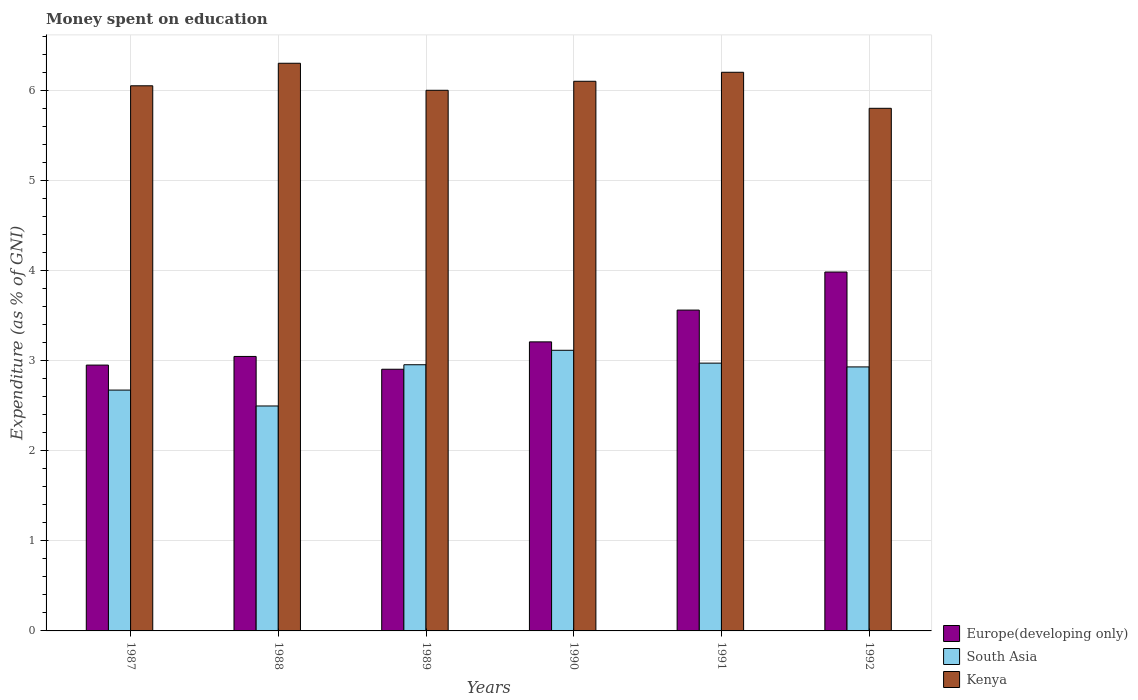How many groups of bars are there?
Offer a very short reply. 6. How many bars are there on the 6th tick from the right?
Ensure brevity in your answer.  3. What is the label of the 6th group of bars from the left?
Offer a very short reply. 1992. In how many cases, is the number of bars for a given year not equal to the number of legend labels?
Your response must be concise. 0. What is the amount of money spent on education in Europe(developing only) in 1987?
Provide a succinct answer. 2.95. What is the total amount of money spent on education in South Asia in the graph?
Make the answer very short. 17.14. What is the difference between the amount of money spent on education in Europe(developing only) in 1987 and that in 1988?
Offer a terse response. -0.1. What is the difference between the amount of money spent on education in Kenya in 1992 and the amount of money spent on education in South Asia in 1990?
Give a very brief answer. 2.69. What is the average amount of money spent on education in Kenya per year?
Provide a short and direct response. 6.08. In the year 1992, what is the difference between the amount of money spent on education in Europe(developing only) and amount of money spent on education in South Asia?
Your answer should be very brief. 1.05. What is the ratio of the amount of money spent on education in South Asia in 1988 to that in 1990?
Your answer should be very brief. 0.8. Is the difference between the amount of money spent on education in Europe(developing only) in 1989 and 1990 greater than the difference between the amount of money spent on education in South Asia in 1989 and 1990?
Make the answer very short. No. What is the difference between the highest and the second highest amount of money spent on education in South Asia?
Offer a terse response. 0.14. What is the difference between the highest and the lowest amount of money spent on education in Europe(developing only)?
Provide a short and direct response. 1.08. Is the sum of the amount of money spent on education in South Asia in 1988 and 1992 greater than the maximum amount of money spent on education in Kenya across all years?
Your answer should be very brief. No. What does the 2nd bar from the left in 1988 represents?
Offer a very short reply. South Asia. Is it the case that in every year, the sum of the amount of money spent on education in Kenya and amount of money spent on education in Europe(developing only) is greater than the amount of money spent on education in South Asia?
Your answer should be very brief. Yes. How many bars are there?
Your answer should be very brief. 18. How many legend labels are there?
Ensure brevity in your answer.  3. How are the legend labels stacked?
Ensure brevity in your answer.  Vertical. What is the title of the graph?
Provide a succinct answer. Money spent on education. Does "Isle of Man" appear as one of the legend labels in the graph?
Your answer should be compact. No. What is the label or title of the X-axis?
Provide a short and direct response. Years. What is the label or title of the Y-axis?
Make the answer very short. Expenditure (as % of GNI). What is the Expenditure (as % of GNI) in Europe(developing only) in 1987?
Provide a short and direct response. 2.95. What is the Expenditure (as % of GNI) in South Asia in 1987?
Your answer should be very brief. 2.67. What is the Expenditure (as % of GNI) of Kenya in 1987?
Your answer should be compact. 6.05. What is the Expenditure (as % of GNI) in Europe(developing only) in 1988?
Keep it short and to the point. 3.05. What is the Expenditure (as % of GNI) of South Asia in 1988?
Make the answer very short. 2.5. What is the Expenditure (as % of GNI) in Europe(developing only) in 1989?
Provide a short and direct response. 2.9. What is the Expenditure (as % of GNI) in South Asia in 1989?
Your answer should be compact. 2.95. What is the Expenditure (as % of GNI) of Kenya in 1989?
Your response must be concise. 6. What is the Expenditure (as % of GNI) of Europe(developing only) in 1990?
Keep it short and to the point. 3.21. What is the Expenditure (as % of GNI) in South Asia in 1990?
Offer a terse response. 3.11. What is the Expenditure (as % of GNI) of Kenya in 1990?
Give a very brief answer. 6.1. What is the Expenditure (as % of GNI) of Europe(developing only) in 1991?
Your answer should be compact. 3.56. What is the Expenditure (as % of GNI) in South Asia in 1991?
Your answer should be very brief. 2.97. What is the Expenditure (as % of GNI) in Europe(developing only) in 1992?
Give a very brief answer. 3.98. What is the Expenditure (as % of GNI) in South Asia in 1992?
Offer a very short reply. 2.93. What is the Expenditure (as % of GNI) in Kenya in 1992?
Keep it short and to the point. 5.8. Across all years, what is the maximum Expenditure (as % of GNI) in Europe(developing only)?
Your answer should be very brief. 3.98. Across all years, what is the maximum Expenditure (as % of GNI) of South Asia?
Give a very brief answer. 3.11. Across all years, what is the maximum Expenditure (as % of GNI) of Kenya?
Your answer should be compact. 6.3. Across all years, what is the minimum Expenditure (as % of GNI) in Europe(developing only)?
Keep it short and to the point. 2.9. Across all years, what is the minimum Expenditure (as % of GNI) of South Asia?
Your answer should be compact. 2.5. Across all years, what is the minimum Expenditure (as % of GNI) of Kenya?
Make the answer very short. 5.8. What is the total Expenditure (as % of GNI) of Europe(developing only) in the graph?
Your answer should be very brief. 19.65. What is the total Expenditure (as % of GNI) of South Asia in the graph?
Provide a succinct answer. 17.14. What is the total Expenditure (as % of GNI) of Kenya in the graph?
Give a very brief answer. 36.45. What is the difference between the Expenditure (as % of GNI) of Europe(developing only) in 1987 and that in 1988?
Offer a terse response. -0.1. What is the difference between the Expenditure (as % of GNI) in South Asia in 1987 and that in 1988?
Your answer should be compact. 0.18. What is the difference between the Expenditure (as % of GNI) of Kenya in 1987 and that in 1988?
Offer a very short reply. -0.25. What is the difference between the Expenditure (as % of GNI) in Europe(developing only) in 1987 and that in 1989?
Give a very brief answer. 0.05. What is the difference between the Expenditure (as % of GNI) of South Asia in 1987 and that in 1989?
Make the answer very short. -0.28. What is the difference between the Expenditure (as % of GNI) of Europe(developing only) in 1987 and that in 1990?
Offer a terse response. -0.26. What is the difference between the Expenditure (as % of GNI) in South Asia in 1987 and that in 1990?
Your response must be concise. -0.44. What is the difference between the Expenditure (as % of GNI) in Kenya in 1987 and that in 1990?
Provide a short and direct response. -0.05. What is the difference between the Expenditure (as % of GNI) in Europe(developing only) in 1987 and that in 1991?
Give a very brief answer. -0.61. What is the difference between the Expenditure (as % of GNI) of South Asia in 1987 and that in 1991?
Offer a terse response. -0.3. What is the difference between the Expenditure (as % of GNI) of Europe(developing only) in 1987 and that in 1992?
Provide a short and direct response. -1.03. What is the difference between the Expenditure (as % of GNI) in South Asia in 1987 and that in 1992?
Offer a terse response. -0.26. What is the difference between the Expenditure (as % of GNI) of Kenya in 1987 and that in 1992?
Provide a short and direct response. 0.25. What is the difference between the Expenditure (as % of GNI) in Europe(developing only) in 1988 and that in 1989?
Offer a terse response. 0.14. What is the difference between the Expenditure (as % of GNI) of South Asia in 1988 and that in 1989?
Make the answer very short. -0.46. What is the difference between the Expenditure (as % of GNI) in Europe(developing only) in 1988 and that in 1990?
Keep it short and to the point. -0.16. What is the difference between the Expenditure (as % of GNI) in South Asia in 1988 and that in 1990?
Offer a very short reply. -0.62. What is the difference between the Expenditure (as % of GNI) in Europe(developing only) in 1988 and that in 1991?
Ensure brevity in your answer.  -0.51. What is the difference between the Expenditure (as % of GNI) in South Asia in 1988 and that in 1991?
Make the answer very short. -0.48. What is the difference between the Expenditure (as % of GNI) in Europe(developing only) in 1988 and that in 1992?
Ensure brevity in your answer.  -0.94. What is the difference between the Expenditure (as % of GNI) of South Asia in 1988 and that in 1992?
Ensure brevity in your answer.  -0.43. What is the difference between the Expenditure (as % of GNI) in Kenya in 1988 and that in 1992?
Provide a short and direct response. 0.5. What is the difference between the Expenditure (as % of GNI) of Europe(developing only) in 1989 and that in 1990?
Give a very brief answer. -0.3. What is the difference between the Expenditure (as % of GNI) of South Asia in 1989 and that in 1990?
Your answer should be compact. -0.16. What is the difference between the Expenditure (as % of GNI) in Europe(developing only) in 1989 and that in 1991?
Provide a short and direct response. -0.66. What is the difference between the Expenditure (as % of GNI) of South Asia in 1989 and that in 1991?
Make the answer very short. -0.02. What is the difference between the Expenditure (as % of GNI) in Europe(developing only) in 1989 and that in 1992?
Keep it short and to the point. -1.08. What is the difference between the Expenditure (as % of GNI) in South Asia in 1989 and that in 1992?
Give a very brief answer. 0.02. What is the difference between the Expenditure (as % of GNI) of Europe(developing only) in 1990 and that in 1991?
Ensure brevity in your answer.  -0.35. What is the difference between the Expenditure (as % of GNI) in South Asia in 1990 and that in 1991?
Offer a terse response. 0.14. What is the difference between the Expenditure (as % of GNI) in Kenya in 1990 and that in 1991?
Provide a short and direct response. -0.1. What is the difference between the Expenditure (as % of GNI) in Europe(developing only) in 1990 and that in 1992?
Offer a terse response. -0.78. What is the difference between the Expenditure (as % of GNI) in South Asia in 1990 and that in 1992?
Your answer should be compact. 0.18. What is the difference between the Expenditure (as % of GNI) in Europe(developing only) in 1991 and that in 1992?
Your response must be concise. -0.42. What is the difference between the Expenditure (as % of GNI) of South Asia in 1991 and that in 1992?
Your response must be concise. 0.04. What is the difference between the Expenditure (as % of GNI) of Europe(developing only) in 1987 and the Expenditure (as % of GNI) of South Asia in 1988?
Provide a succinct answer. 0.45. What is the difference between the Expenditure (as % of GNI) of Europe(developing only) in 1987 and the Expenditure (as % of GNI) of Kenya in 1988?
Keep it short and to the point. -3.35. What is the difference between the Expenditure (as % of GNI) of South Asia in 1987 and the Expenditure (as % of GNI) of Kenya in 1988?
Make the answer very short. -3.63. What is the difference between the Expenditure (as % of GNI) in Europe(developing only) in 1987 and the Expenditure (as % of GNI) in South Asia in 1989?
Your answer should be compact. -0. What is the difference between the Expenditure (as % of GNI) of Europe(developing only) in 1987 and the Expenditure (as % of GNI) of Kenya in 1989?
Give a very brief answer. -3.05. What is the difference between the Expenditure (as % of GNI) in South Asia in 1987 and the Expenditure (as % of GNI) in Kenya in 1989?
Provide a short and direct response. -3.33. What is the difference between the Expenditure (as % of GNI) in Europe(developing only) in 1987 and the Expenditure (as % of GNI) in South Asia in 1990?
Make the answer very short. -0.16. What is the difference between the Expenditure (as % of GNI) in Europe(developing only) in 1987 and the Expenditure (as % of GNI) in Kenya in 1990?
Your response must be concise. -3.15. What is the difference between the Expenditure (as % of GNI) in South Asia in 1987 and the Expenditure (as % of GNI) in Kenya in 1990?
Provide a short and direct response. -3.43. What is the difference between the Expenditure (as % of GNI) in Europe(developing only) in 1987 and the Expenditure (as % of GNI) in South Asia in 1991?
Provide a short and direct response. -0.02. What is the difference between the Expenditure (as % of GNI) in Europe(developing only) in 1987 and the Expenditure (as % of GNI) in Kenya in 1991?
Your answer should be very brief. -3.25. What is the difference between the Expenditure (as % of GNI) of South Asia in 1987 and the Expenditure (as % of GNI) of Kenya in 1991?
Provide a short and direct response. -3.53. What is the difference between the Expenditure (as % of GNI) of Europe(developing only) in 1987 and the Expenditure (as % of GNI) of South Asia in 1992?
Give a very brief answer. 0.02. What is the difference between the Expenditure (as % of GNI) in Europe(developing only) in 1987 and the Expenditure (as % of GNI) in Kenya in 1992?
Provide a short and direct response. -2.85. What is the difference between the Expenditure (as % of GNI) in South Asia in 1987 and the Expenditure (as % of GNI) in Kenya in 1992?
Your response must be concise. -3.13. What is the difference between the Expenditure (as % of GNI) of Europe(developing only) in 1988 and the Expenditure (as % of GNI) of South Asia in 1989?
Provide a succinct answer. 0.09. What is the difference between the Expenditure (as % of GNI) in Europe(developing only) in 1988 and the Expenditure (as % of GNI) in Kenya in 1989?
Give a very brief answer. -2.95. What is the difference between the Expenditure (as % of GNI) in South Asia in 1988 and the Expenditure (as % of GNI) in Kenya in 1989?
Offer a very short reply. -3.5. What is the difference between the Expenditure (as % of GNI) of Europe(developing only) in 1988 and the Expenditure (as % of GNI) of South Asia in 1990?
Provide a succinct answer. -0.07. What is the difference between the Expenditure (as % of GNI) of Europe(developing only) in 1988 and the Expenditure (as % of GNI) of Kenya in 1990?
Your response must be concise. -3.05. What is the difference between the Expenditure (as % of GNI) in South Asia in 1988 and the Expenditure (as % of GNI) in Kenya in 1990?
Offer a terse response. -3.6. What is the difference between the Expenditure (as % of GNI) in Europe(developing only) in 1988 and the Expenditure (as % of GNI) in South Asia in 1991?
Your answer should be compact. 0.07. What is the difference between the Expenditure (as % of GNI) in Europe(developing only) in 1988 and the Expenditure (as % of GNI) in Kenya in 1991?
Your response must be concise. -3.15. What is the difference between the Expenditure (as % of GNI) of South Asia in 1988 and the Expenditure (as % of GNI) of Kenya in 1991?
Keep it short and to the point. -3.7. What is the difference between the Expenditure (as % of GNI) in Europe(developing only) in 1988 and the Expenditure (as % of GNI) in South Asia in 1992?
Ensure brevity in your answer.  0.12. What is the difference between the Expenditure (as % of GNI) of Europe(developing only) in 1988 and the Expenditure (as % of GNI) of Kenya in 1992?
Keep it short and to the point. -2.75. What is the difference between the Expenditure (as % of GNI) in South Asia in 1988 and the Expenditure (as % of GNI) in Kenya in 1992?
Make the answer very short. -3.3. What is the difference between the Expenditure (as % of GNI) of Europe(developing only) in 1989 and the Expenditure (as % of GNI) of South Asia in 1990?
Your answer should be very brief. -0.21. What is the difference between the Expenditure (as % of GNI) of Europe(developing only) in 1989 and the Expenditure (as % of GNI) of Kenya in 1990?
Your answer should be compact. -3.2. What is the difference between the Expenditure (as % of GNI) in South Asia in 1989 and the Expenditure (as % of GNI) in Kenya in 1990?
Make the answer very short. -3.15. What is the difference between the Expenditure (as % of GNI) of Europe(developing only) in 1989 and the Expenditure (as % of GNI) of South Asia in 1991?
Provide a short and direct response. -0.07. What is the difference between the Expenditure (as % of GNI) of Europe(developing only) in 1989 and the Expenditure (as % of GNI) of Kenya in 1991?
Your response must be concise. -3.3. What is the difference between the Expenditure (as % of GNI) of South Asia in 1989 and the Expenditure (as % of GNI) of Kenya in 1991?
Ensure brevity in your answer.  -3.25. What is the difference between the Expenditure (as % of GNI) in Europe(developing only) in 1989 and the Expenditure (as % of GNI) in South Asia in 1992?
Make the answer very short. -0.03. What is the difference between the Expenditure (as % of GNI) of Europe(developing only) in 1989 and the Expenditure (as % of GNI) of Kenya in 1992?
Offer a terse response. -2.9. What is the difference between the Expenditure (as % of GNI) of South Asia in 1989 and the Expenditure (as % of GNI) of Kenya in 1992?
Provide a succinct answer. -2.85. What is the difference between the Expenditure (as % of GNI) of Europe(developing only) in 1990 and the Expenditure (as % of GNI) of South Asia in 1991?
Ensure brevity in your answer.  0.24. What is the difference between the Expenditure (as % of GNI) of Europe(developing only) in 1990 and the Expenditure (as % of GNI) of Kenya in 1991?
Keep it short and to the point. -2.99. What is the difference between the Expenditure (as % of GNI) in South Asia in 1990 and the Expenditure (as % of GNI) in Kenya in 1991?
Offer a terse response. -3.09. What is the difference between the Expenditure (as % of GNI) in Europe(developing only) in 1990 and the Expenditure (as % of GNI) in South Asia in 1992?
Provide a short and direct response. 0.28. What is the difference between the Expenditure (as % of GNI) of Europe(developing only) in 1990 and the Expenditure (as % of GNI) of Kenya in 1992?
Your answer should be compact. -2.59. What is the difference between the Expenditure (as % of GNI) in South Asia in 1990 and the Expenditure (as % of GNI) in Kenya in 1992?
Your answer should be compact. -2.69. What is the difference between the Expenditure (as % of GNI) of Europe(developing only) in 1991 and the Expenditure (as % of GNI) of South Asia in 1992?
Your answer should be compact. 0.63. What is the difference between the Expenditure (as % of GNI) in Europe(developing only) in 1991 and the Expenditure (as % of GNI) in Kenya in 1992?
Offer a very short reply. -2.24. What is the difference between the Expenditure (as % of GNI) in South Asia in 1991 and the Expenditure (as % of GNI) in Kenya in 1992?
Make the answer very short. -2.83. What is the average Expenditure (as % of GNI) in Europe(developing only) per year?
Keep it short and to the point. 3.28. What is the average Expenditure (as % of GNI) in South Asia per year?
Provide a short and direct response. 2.86. What is the average Expenditure (as % of GNI) in Kenya per year?
Your response must be concise. 6.08. In the year 1987, what is the difference between the Expenditure (as % of GNI) of Europe(developing only) and Expenditure (as % of GNI) of South Asia?
Your answer should be very brief. 0.28. In the year 1987, what is the difference between the Expenditure (as % of GNI) of Europe(developing only) and Expenditure (as % of GNI) of Kenya?
Ensure brevity in your answer.  -3.1. In the year 1987, what is the difference between the Expenditure (as % of GNI) of South Asia and Expenditure (as % of GNI) of Kenya?
Offer a very short reply. -3.38. In the year 1988, what is the difference between the Expenditure (as % of GNI) in Europe(developing only) and Expenditure (as % of GNI) in South Asia?
Ensure brevity in your answer.  0.55. In the year 1988, what is the difference between the Expenditure (as % of GNI) in Europe(developing only) and Expenditure (as % of GNI) in Kenya?
Make the answer very short. -3.25. In the year 1988, what is the difference between the Expenditure (as % of GNI) in South Asia and Expenditure (as % of GNI) in Kenya?
Provide a succinct answer. -3.8. In the year 1989, what is the difference between the Expenditure (as % of GNI) of Europe(developing only) and Expenditure (as % of GNI) of South Asia?
Provide a succinct answer. -0.05. In the year 1989, what is the difference between the Expenditure (as % of GNI) of Europe(developing only) and Expenditure (as % of GNI) of Kenya?
Offer a terse response. -3.1. In the year 1989, what is the difference between the Expenditure (as % of GNI) in South Asia and Expenditure (as % of GNI) in Kenya?
Provide a short and direct response. -3.05. In the year 1990, what is the difference between the Expenditure (as % of GNI) in Europe(developing only) and Expenditure (as % of GNI) in South Asia?
Ensure brevity in your answer.  0.09. In the year 1990, what is the difference between the Expenditure (as % of GNI) of Europe(developing only) and Expenditure (as % of GNI) of Kenya?
Provide a short and direct response. -2.89. In the year 1990, what is the difference between the Expenditure (as % of GNI) in South Asia and Expenditure (as % of GNI) in Kenya?
Your answer should be very brief. -2.99. In the year 1991, what is the difference between the Expenditure (as % of GNI) in Europe(developing only) and Expenditure (as % of GNI) in South Asia?
Give a very brief answer. 0.59. In the year 1991, what is the difference between the Expenditure (as % of GNI) of Europe(developing only) and Expenditure (as % of GNI) of Kenya?
Provide a succinct answer. -2.64. In the year 1991, what is the difference between the Expenditure (as % of GNI) in South Asia and Expenditure (as % of GNI) in Kenya?
Keep it short and to the point. -3.23. In the year 1992, what is the difference between the Expenditure (as % of GNI) of Europe(developing only) and Expenditure (as % of GNI) of South Asia?
Make the answer very short. 1.05. In the year 1992, what is the difference between the Expenditure (as % of GNI) of Europe(developing only) and Expenditure (as % of GNI) of Kenya?
Offer a terse response. -1.82. In the year 1992, what is the difference between the Expenditure (as % of GNI) in South Asia and Expenditure (as % of GNI) in Kenya?
Your response must be concise. -2.87. What is the ratio of the Expenditure (as % of GNI) of Europe(developing only) in 1987 to that in 1988?
Your answer should be compact. 0.97. What is the ratio of the Expenditure (as % of GNI) of South Asia in 1987 to that in 1988?
Give a very brief answer. 1.07. What is the ratio of the Expenditure (as % of GNI) of Kenya in 1987 to that in 1988?
Ensure brevity in your answer.  0.96. What is the ratio of the Expenditure (as % of GNI) in Europe(developing only) in 1987 to that in 1989?
Make the answer very short. 1.02. What is the ratio of the Expenditure (as % of GNI) of South Asia in 1987 to that in 1989?
Give a very brief answer. 0.9. What is the ratio of the Expenditure (as % of GNI) in Kenya in 1987 to that in 1989?
Provide a short and direct response. 1.01. What is the ratio of the Expenditure (as % of GNI) in Europe(developing only) in 1987 to that in 1990?
Your response must be concise. 0.92. What is the ratio of the Expenditure (as % of GNI) of South Asia in 1987 to that in 1990?
Your answer should be very brief. 0.86. What is the ratio of the Expenditure (as % of GNI) of Europe(developing only) in 1987 to that in 1991?
Ensure brevity in your answer.  0.83. What is the ratio of the Expenditure (as % of GNI) in South Asia in 1987 to that in 1991?
Offer a terse response. 0.9. What is the ratio of the Expenditure (as % of GNI) in Kenya in 1987 to that in 1991?
Provide a succinct answer. 0.98. What is the ratio of the Expenditure (as % of GNI) of Europe(developing only) in 1987 to that in 1992?
Your response must be concise. 0.74. What is the ratio of the Expenditure (as % of GNI) in South Asia in 1987 to that in 1992?
Make the answer very short. 0.91. What is the ratio of the Expenditure (as % of GNI) of Kenya in 1987 to that in 1992?
Keep it short and to the point. 1.04. What is the ratio of the Expenditure (as % of GNI) of Europe(developing only) in 1988 to that in 1989?
Your response must be concise. 1.05. What is the ratio of the Expenditure (as % of GNI) of South Asia in 1988 to that in 1989?
Provide a short and direct response. 0.85. What is the ratio of the Expenditure (as % of GNI) in Kenya in 1988 to that in 1989?
Make the answer very short. 1.05. What is the ratio of the Expenditure (as % of GNI) in Europe(developing only) in 1988 to that in 1990?
Ensure brevity in your answer.  0.95. What is the ratio of the Expenditure (as % of GNI) of South Asia in 1988 to that in 1990?
Offer a terse response. 0.8. What is the ratio of the Expenditure (as % of GNI) in Kenya in 1988 to that in 1990?
Keep it short and to the point. 1.03. What is the ratio of the Expenditure (as % of GNI) in Europe(developing only) in 1988 to that in 1991?
Your answer should be very brief. 0.86. What is the ratio of the Expenditure (as % of GNI) in South Asia in 1988 to that in 1991?
Offer a very short reply. 0.84. What is the ratio of the Expenditure (as % of GNI) of Kenya in 1988 to that in 1991?
Give a very brief answer. 1.02. What is the ratio of the Expenditure (as % of GNI) in Europe(developing only) in 1988 to that in 1992?
Provide a succinct answer. 0.76. What is the ratio of the Expenditure (as % of GNI) in South Asia in 1988 to that in 1992?
Make the answer very short. 0.85. What is the ratio of the Expenditure (as % of GNI) of Kenya in 1988 to that in 1992?
Offer a very short reply. 1.09. What is the ratio of the Expenditure (as % of GNI) of Europe(developing only) in 1989 to that in 1990?
Ensure brevity in your answer.  0.91. What is the ratio of the Expenditure (as % of GNI) in South Asia in 1989 to that in 1990?
Ensure brevity in your answer.  0.95. What is the ratio of the Expenditure (as % of GNI) of Kenya in 1989 to that in 1990?
Ensure brevity in your answer.  0.98. What is the ratio of the Expenditure (as % of GNI) of Europe(developing only) in 1989 to that in 1991?
Ensure brevity in your answer.  0.82. What is the ratio of the Expenditure (as % of GNI) of Europe(developing only) in 1989 to that in 1992?
Your response must be concise. 0.73. What is the ratio of the Expenditure (as % of GNI) of South Asia in 1989 to that in 1992?
Your answer should be very brief. 1.01. What is the ratio of the Expenditure (as % of GNI) in Kenya in 1989 to that in 1992?
Ensure brevity in your answer.  1.03. What is the ratio of the Expenditure (as % of GNI) in Europe(developing only) in 1990 to that in 1991?
Make the answer very short. 0.9. What is the ratio of the Expenditure (as % of GNI) of South Asia in 1990 to that in 1991?
Make the answer very short. 1.05. What is the ratio of the Expenditure (as % of GNI) in Kenya in 1990 to that in 1991?
Your answer should be compact. 0.98. What is the ratio of the Expenditure (as % of GNI) of Europe(developing only) in 1990 to that in 1992?
Provide a succinct answer. 0.81. What is the ratio of the Expenditure (as % of GNI) in South Asia in 1990 to that in 1992?
Provide a succinct answer. 1.06. What is the ratio of the Expenditure (as % of GNI) of Kenya in 1990 to that in 1992?
Offer a terse response. 1.05. What is the ratio of the Expenditure (as % of GNI) of Europe(developing only) in 1991 to that in 1992?
Provide a short and direct response. 0.89. What is the ratio of the Expenditure (as % of GNI) in South Asia in 1991 to that in 1992?
Your response must be concise. 1.01. What is the ratio of the Expenditure (as % of GNI) of Kenya in 1991 to that in 1992?
Your answer should be very brief. 1.07. What is the difference between the highest and the second highest Expenditure (as % of GNI) of Europe(developing only)?
Offer a terse response. 0.42. What is the difference between the highest and the second highest Expenditure (as % of GNI) in South Asia?
Offer a very short reply. 0.14. What is the difference between the highest and the lowest Expenditure (as % of GNI) of Europe(developing only)?
Ensure brevity in your answer.  1.08. What is the difference between the highest and the lowest Expenditure (as % of GNI) of South Asia?
Your response must be concise. 0.62. 